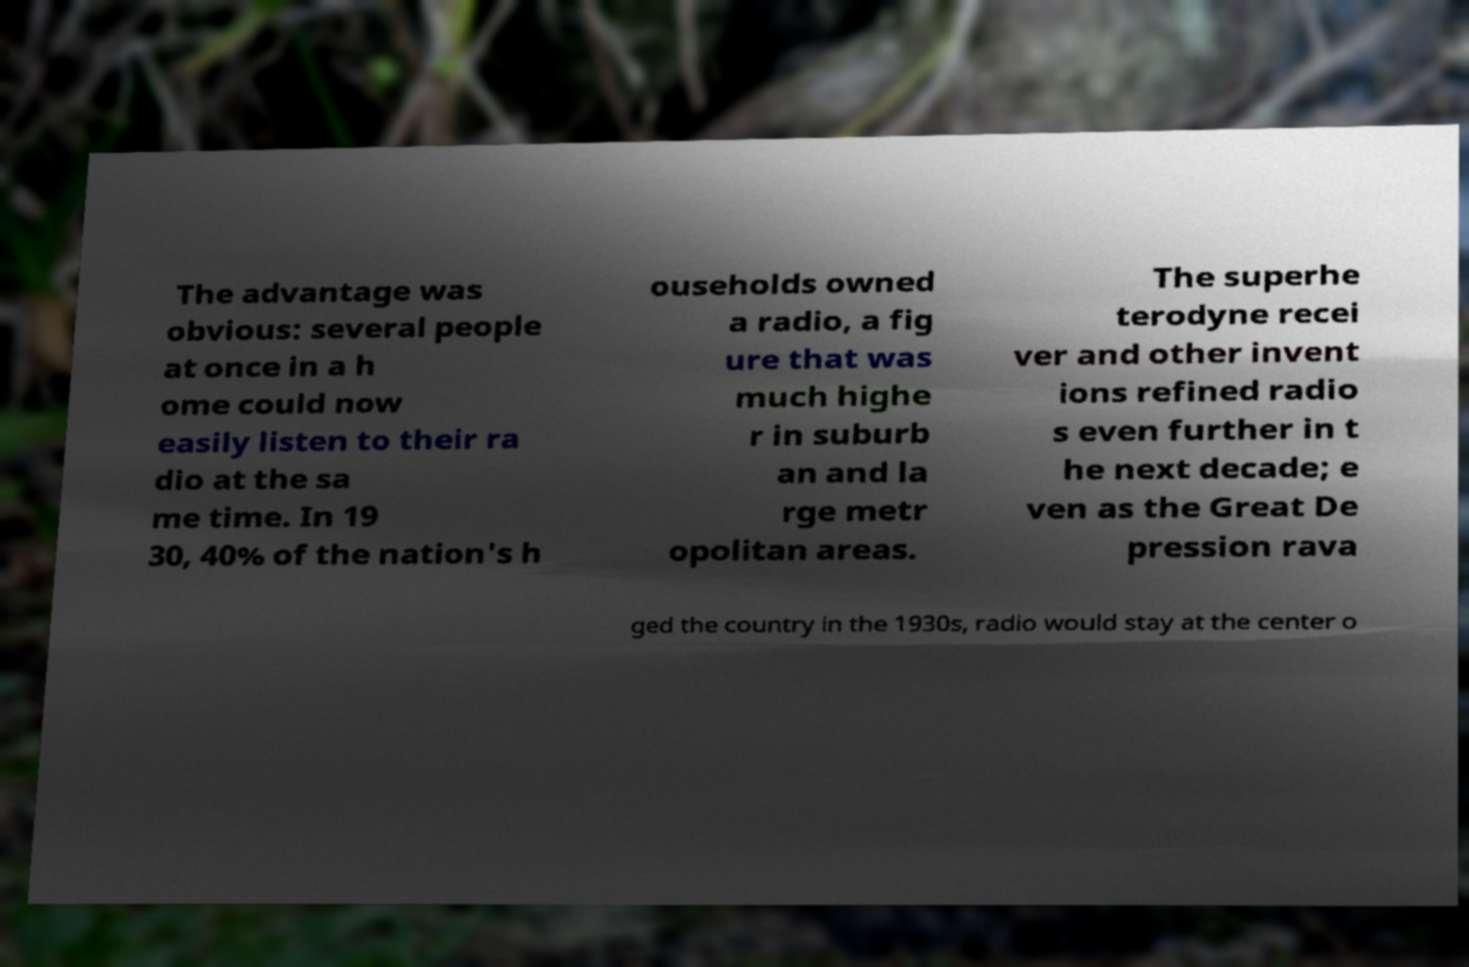Can you accurately transcribe the text from the provided image for me? The advantage was obvious: several people at once in a h ome could now easily listen to their ra dio at the sa me time. In 19 30, 40% of the nation's h ouseholds owned a radio, a fig ure that was much highe r in suburb an and la rge metr opolitan areas. The superhe terodyne recei ver and other invent ions refined radio s even further in t he next decade; e ven as the Great De pression rava ged the country in the 1930s, radio would stay at the center o 